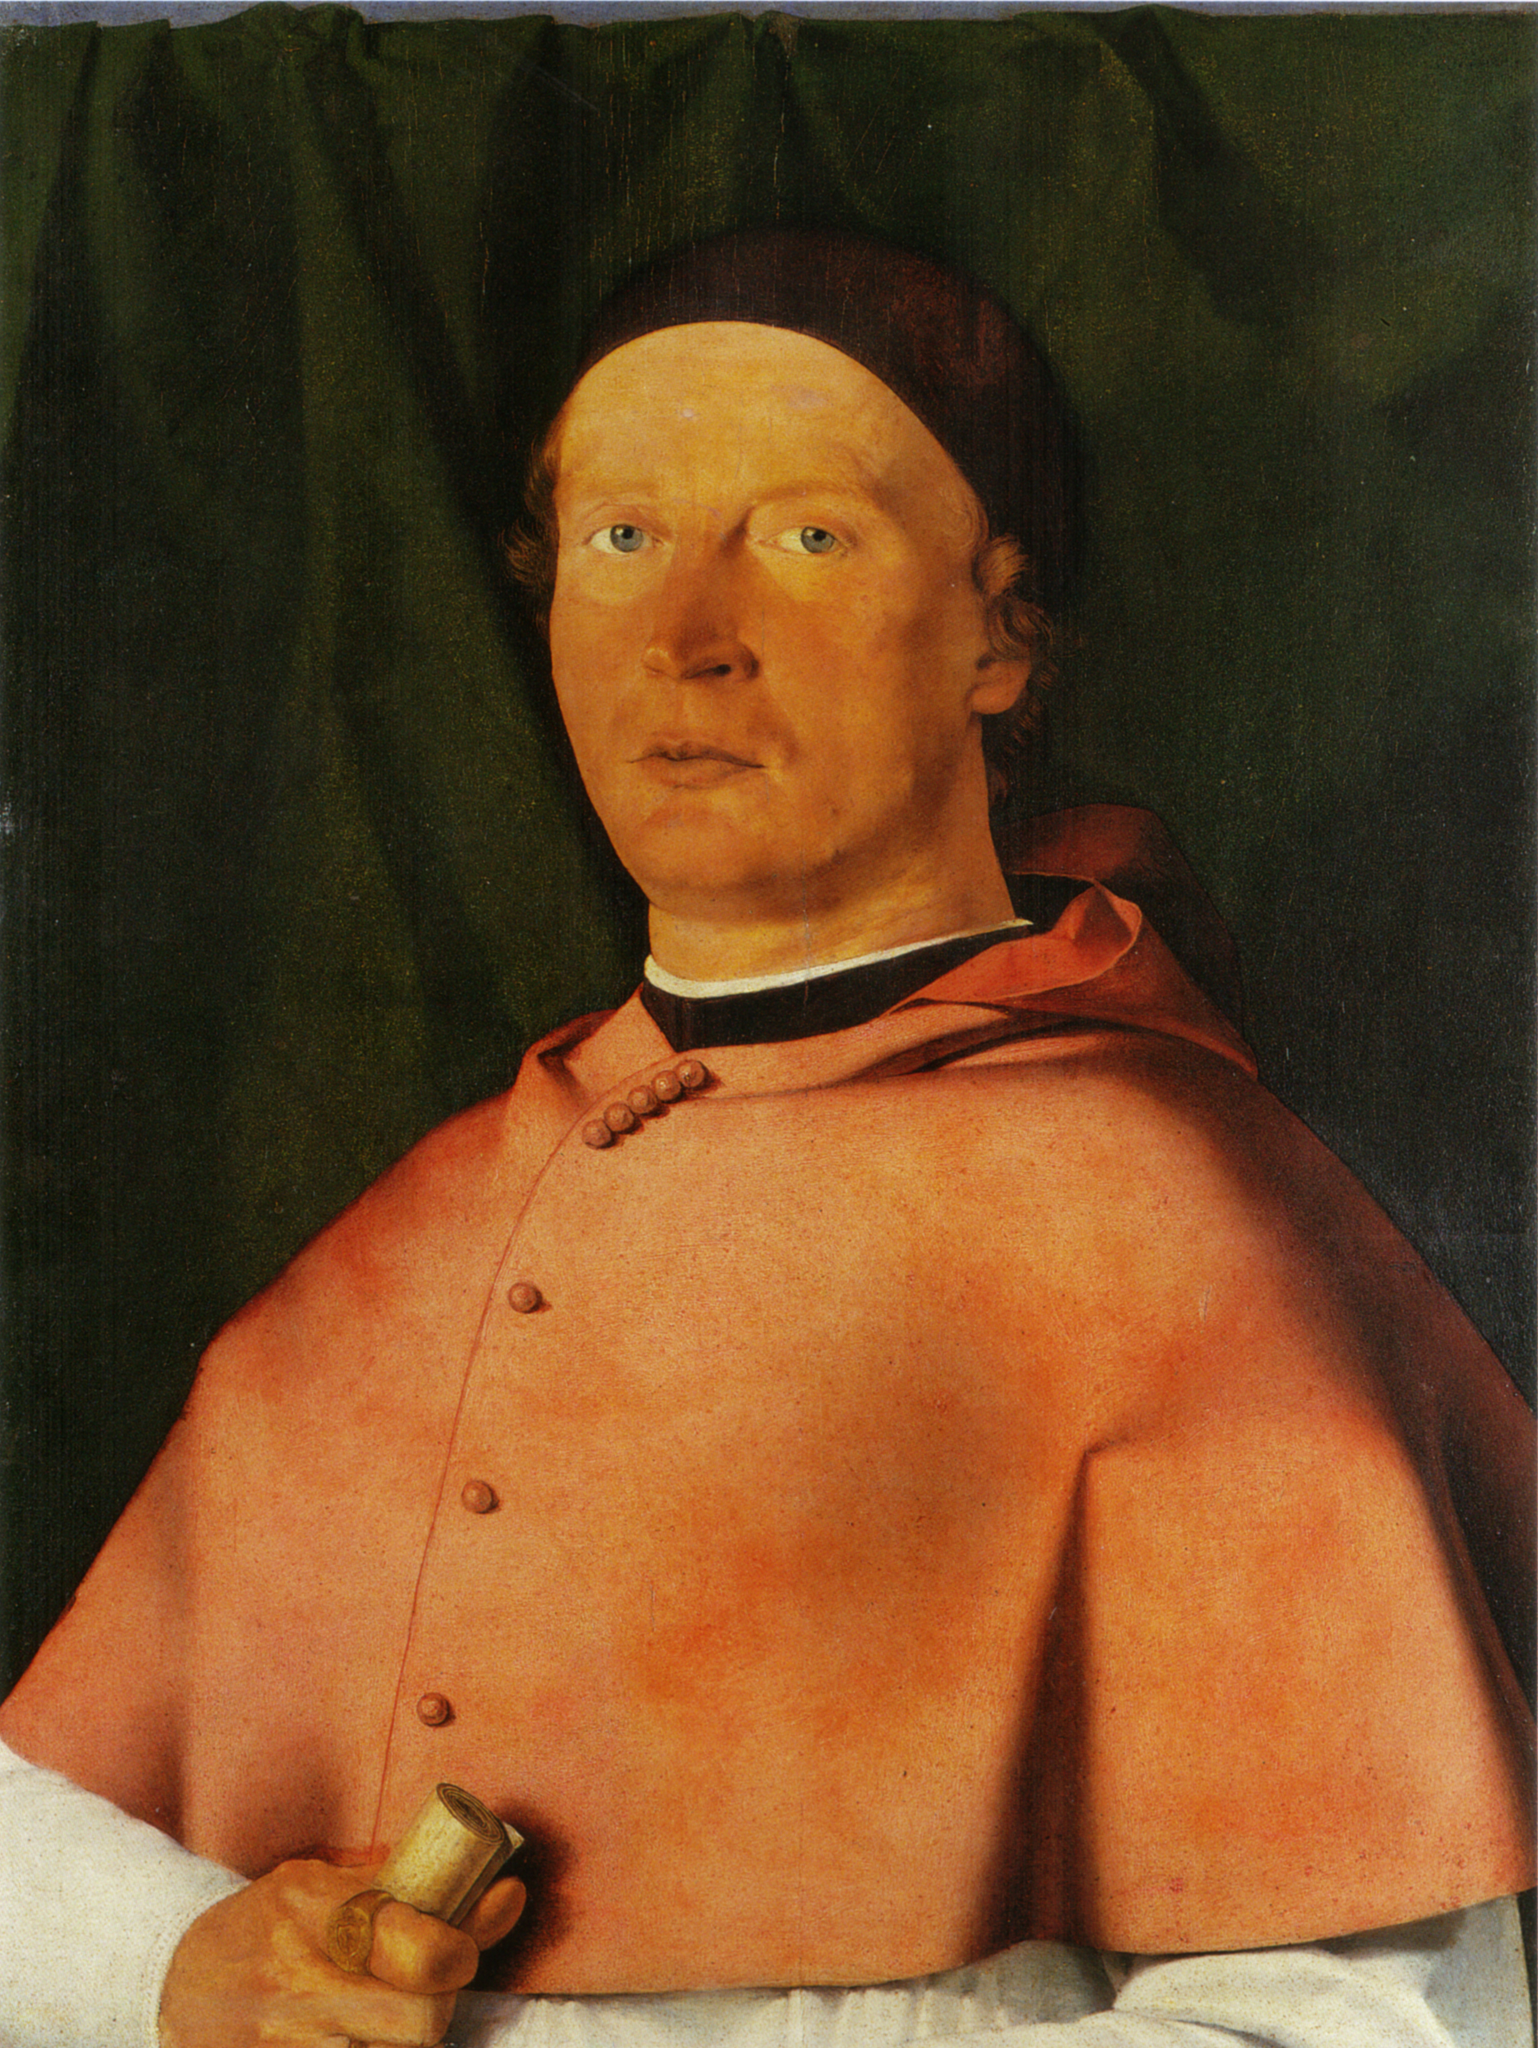What kind of background do you think the man in the painting has? Given the man’s attire and the detailed, realistic depiction, it is plausible that he holds a significant position, perhaps in the church, as a scholar, or as a governmental official. His red robe and formal cap could indicate a high rank or a ceremonial role, while the small document in his hand might point to his involvement in official duties or intellectual pursuits. The overall composition and the careful attention to detail in the painting suggest that the man is someone of considerable importance and status. 